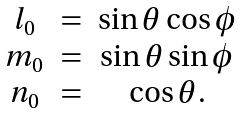<formula> <loc_0><loc_0><loc_500><loc_500>\begin{array} { c c c } l _ { 0 } & = & \sin \theta \cos \phi \\ m _ { 0 } & = & \sin \theta \sin \phi \\ n _ { 0 } & = & \cos \theta . \end{array}</formula> 